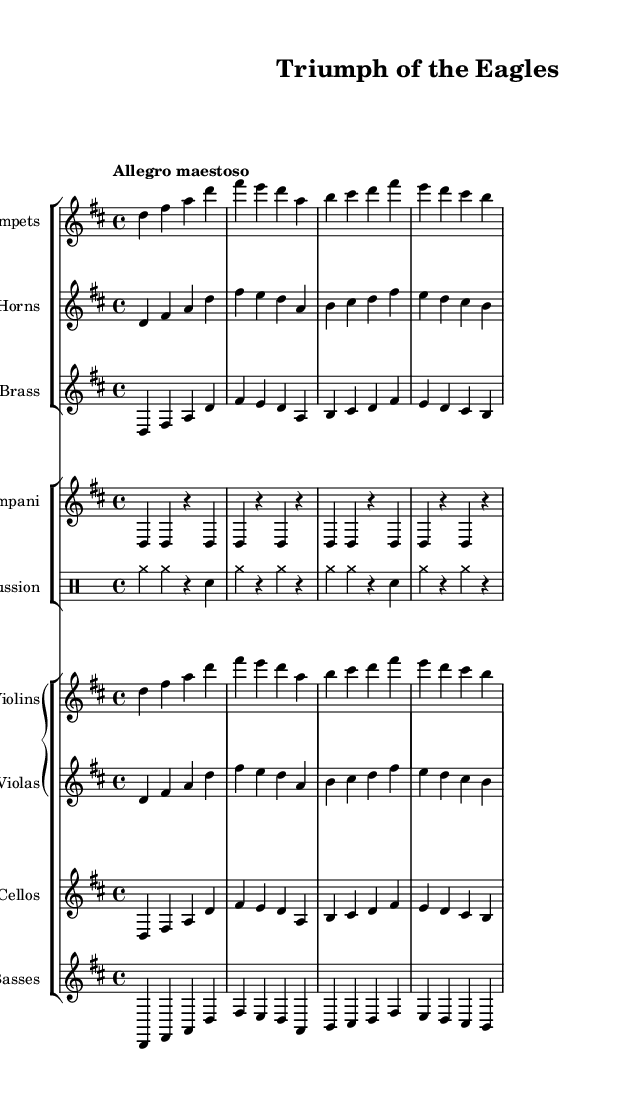What is the key signature of this music? The key signature is D major, which has two sharps: F# and C#. This can be determined by identifying the sharp symbols placed at the beginning of the staff, which indicate the notes that are played sharp in this key.
Answer: D major What is the time signature of this music? The time signature is 4/4, which means there are four beats in each measure and a quarter note gets one beat. This can be found at the beginning of the score where the time signature is indicated as "4/4".
Answer: 4/4 What is the tempo marking for this piece? The tempo marking is "Allegro maestoso", which denotes a lively and majestic pace to the music. This is specified at the beginning of the score and provides guidance on how the piece should be performed.
Answer: Allegro maestoso Which instruments are included in the brass section? The brass section includes Trumpets, French Horns, and Low Brass. This can be determined from the staff groupings listed at the beginning of the score, where each instrument is labeled accordingly.
Answer: Trumpets, French Horns, Low Brass What rhythmic pattern does the Timpani primarily follow? The Timpani primarily follows a pattern of quarter notes followed by rests, specifically alternating between a D note and rests. This can be observed in the written part for the Timpani where the symbols indicate which notes are played and where the rests occur.
Answer: D, r How many measures are present in the musical score? There are four measures in the score, as indicated by the separation of notes and rests across the staff. Each group of notes between the vertical bar lines represents a measure, and by counting those, we find there are four.
Answer: 4 What is the main theme played in the strings section? The main theme in the strings section consists of the notes D, F#, A, and repeated patterns, portraying the celebratory nature of the piece. This can be seen by reviewing the music notation presented in both the Violin and Viola staves.
Answer: D, F#, A 